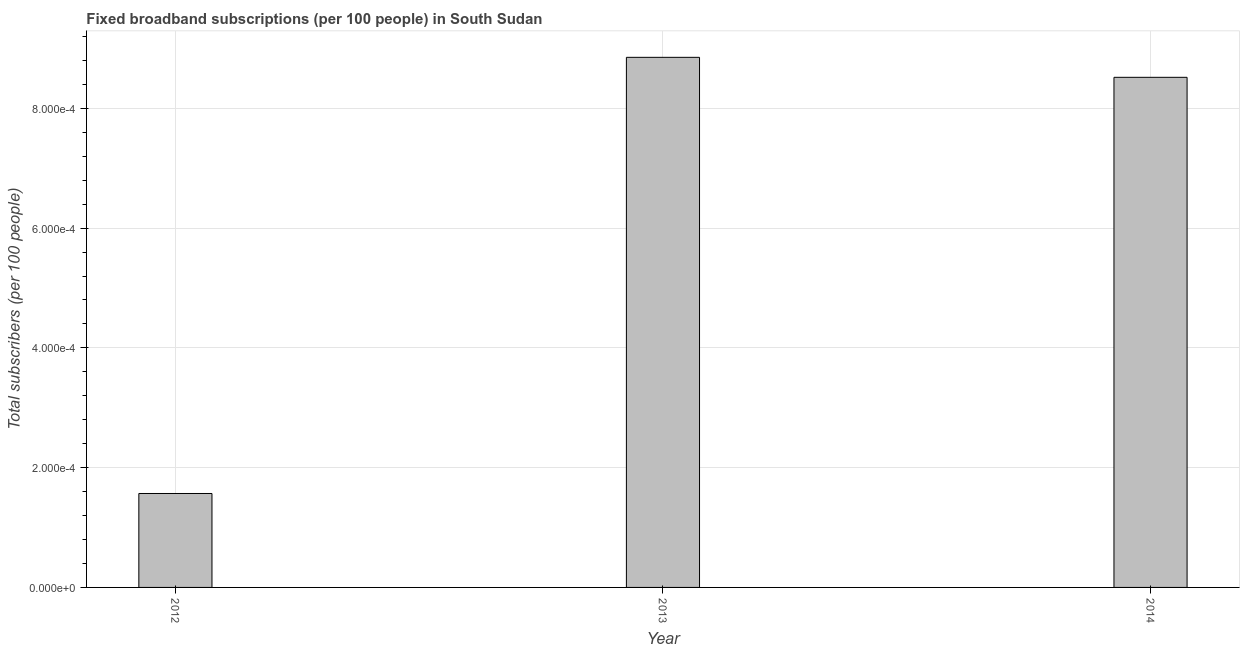Does the graph contain any zero values?
Offer a very short reply. No. Does the graph contain grids?
Make the answer very short. Yes. What is the title of the graph?
Offer a very short reply. Fixed broadband subscriptions (per 100 people) in South Sudan. What is the label or title of the Y-axis?
Provide a succinct answer. Total subscribers (per 100 people). What is the total number of fixed broadband subscriptions in 2013?
Keep it short and to the point. 0. Across all years, what is the maximum total number of fixed broadband subscriptions?
Keep it short and to the point. 0. Across all years, what is the minimum total number of fixed broadband subscriptions?
Ensure brevity in your answer.  0. What is the sum of the total number of fixed broadband subscriptions?
Give a very brief answer. 0. What is the median total number of fixed broadband subscriptions?
Ensure brevity in your answer.  0. In how many years, is the total number of fixed broadband subscriptions greater than 4e-05 ?
Ensure brevity in your answer.  3. Do a majority of the years between 2014 and 2012 (inclusive) have total number of fixed broadband subscriptions greater than 0.00068 ?
Your response must be concise. Yes. What is the ratio of the total number of fixed broadband subscriptions in 2012 to that in 2014?
Give a very brief answer. 0.18. Is the total number of fixed broadband subscriptions in 2012 less than that in 2014?
Ensure brevity in your answer.  Yes. Is the difference between the total number of fixed broadband subscriptions in 2012 and 2014 greater than the difference between any two years?
Offer a terse response. No. Is the sum of the total number of fixed broadband subscriptions in 2012 and 2014 greater than the maximum total number of fixed broadband subscriptions across all years?
Give a very brief answer. Yes. What is the difference between the highest and the lowest total number of fixed broadband subscriptions?
Provide a short and direct response. 0. How many bars are there?
Keep it short and to the point. 3. What is the Total subscribers (per 100 people) in 2012?
Provide a short and direct response. 0. What is the Total subscribers (per 100 people) in 2013?
Your response must be concise. 0. What is the Total subscribers (per 100 people) of 2014?
Your answer should be compact. 0. What is the difference between the Total subscribers (per 100 people) in 2012 and 2013?
Make the answer very short. -0. What is the difference between the Total subscribers (per 100 people) in 2012 and 2014?
Your answer should be very brief. -0. What is the difference between the Total subscribers (per 100 people) in 2013 and 2014?
Offer a terse response. 3e-5. What is the ratio of the Total subscribers (per 100 people) in 2012 to that in 2013?
Ensure brevity in your answer.  0.18. What is the ratio of the Total subscribers (per 100 people) in 2012 to that in 2014?
Offer a very short reply. 0.18. What is the ratio of the Total subscribers (per 100 people) in 2013 to that in 2014?
Offer a very short reply. 1.04. 